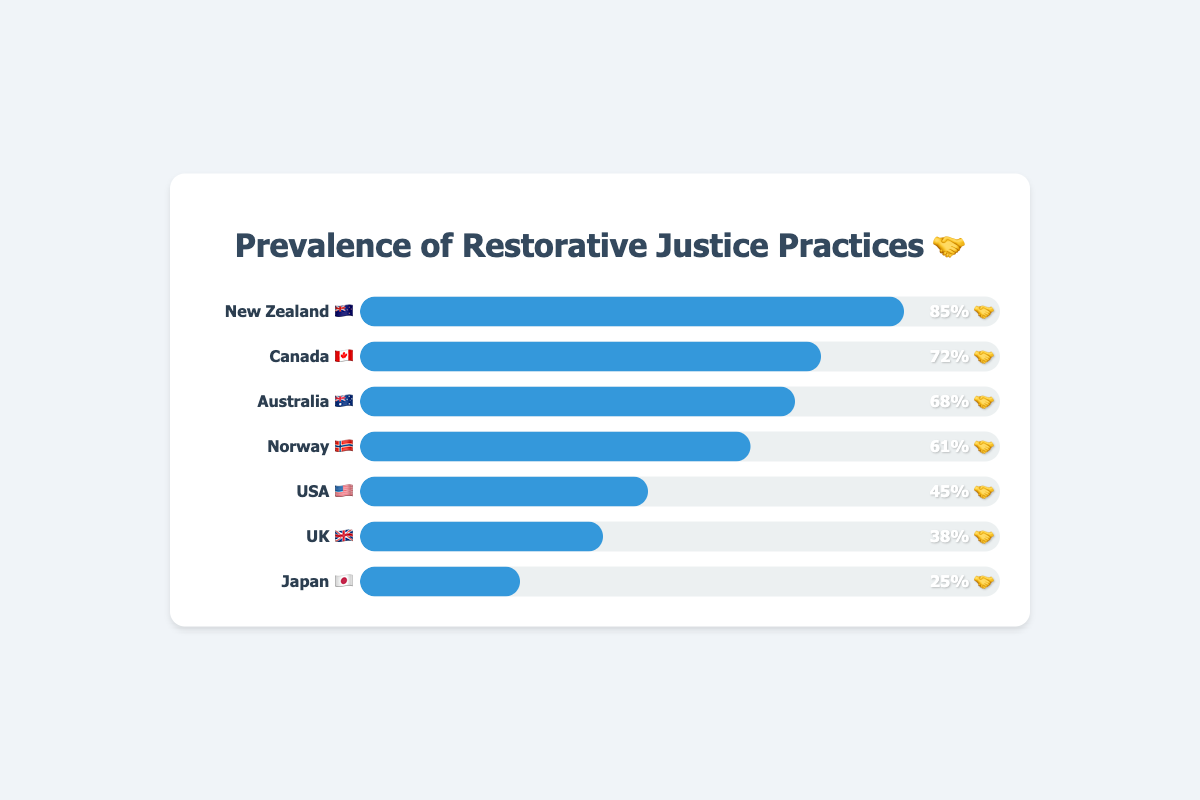What's the title of the chart? The title is located at the top of the chart, visually distinguished from other text elements. It summarizes the main subject of the figure.
Answer: Prevalence of Restorative Justice Practices 🤝 Which country has the highest prevalence of restorative justice practices? By examining the progress bars' lengths, the country with the longest bar has the highest prevalence. The label indicates the name of this country.
Answer: New Zealand 🇳🇿 Which country has the lowest prevalence of restorative justice practices? The country with the shortest progress bar represents the lowest prevalence. The label next to the shortest bar indicates the name of this country.
Answer: Japan 🇯🇵 What is the difference in the prevalence of restorative justice practices between Canada 🇨🇦 and the USA 🇺🇸? The prevalence is 72% for Canada and 45% for the USA. Subtract the lower prevalence from the higher one to find the difference: 72% - 45% = 27%
Answer: 27% Which countries have a prevalence of restorative justice practices greater than 50%? Identify the countries with progress bars longer than the halfway mark, which corresponds to 50% in each bar.
Answer: New Zealand 🇳🇿, Canada 🇨🇦, Australia 🇦🇺, Norway 🇳🇴 What is the total prevalence of restorative justice practices for all countries combined? Add the prevalence percentages for all the countries: 85% + 72% + 68% + 61% + 45% + 38% + 25% = 394%
Answer: 394% Which country has a higher prevalence of restorative justice practices, the UK 🇬🇧 or Australia 🇦🇺? Compare the lengths of the progress bars. The bar for Australia is longer than the one for the UK.
Answer: Australia 🇦🇺 What is the average prevalence of restorative justice practices among the listed countries? Add the prevalence percentages for all countries (85% + 72% + 68% + 61% + 45% + 38% + 25%) and then divide by the number of countries (7): 394% / 7 ≈ 56.29%
Answer: 56.29% How does the prevalence in Norway 🇳🇴 compare to that in Japan 🇯🇵? Norway's prevalence is 61%, and Japan's is 25%. The difference is 61% - 25% = 36%. Norway's prevalence is higher by this margin.
Answer: 36% What proportion of the countries have a prevalence rate below 50%? Count countries with less than 50% prevalence (USA, UK, and Japan = 3), then divide by the total number of countries (7): 3 / 7 ≈ 0.43
Answer: 0.43 